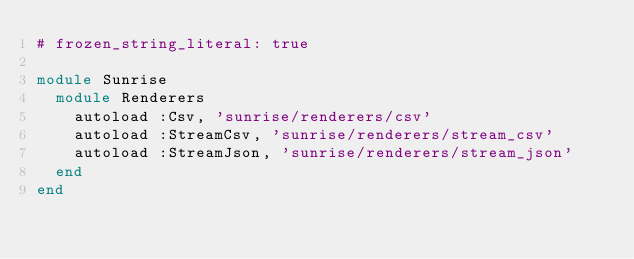Convert code to text. <code><loc_0><loc_0><loc_500><loc_500><_Ruby_># frozen_string_literal: true

module Sunrise
  module Renderers
    autoload :Csv, 'sunrise/renderers/csv'
    autoload :StreamCsv, 'sunrise/renderers/stream_csv'
    autoload :StreamJson, 'sunrise/renderers/stream_json'
  end
end
</code> 